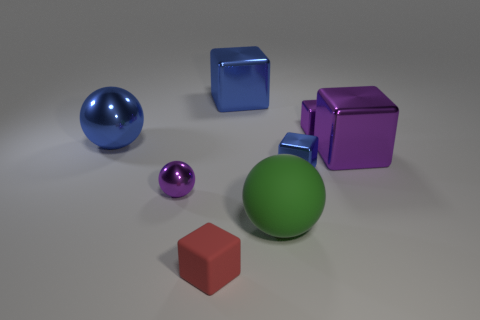Is there a purple sphere of the same size as the red cube?
Provide a short and direct response. Yes. Is the number of brown metal objects less than the number of big metal objects?
Provide a succinct answer. Yes. How many cylinders are either blue matte objects or rubber things?
Your answer should be very brief. 0. How many blocks have the same color as the small ball?
Keep it short and to the point. 2. What size is the purple metal object that is both to the left of the large purple metal cube and behind the tiny blue thing?
Offer a terse response. Small. Is the number of tiny blue metallic cubes that are in front of the small metal sphere less than the number of small cyan metallic balls?
Offer a terse response. No. Is the material of the tiny purple cube the same as the green sphere?
Your answer should be compact. No. What number of objects are small brown rubber cubes or small purple things?
Give a very brief answer. 2. What number of other tiny objects are made of the same material as the green object?
Give a very brief answer. 1. There is a blue shiny object that is the same shape as the green thing; what size is it?
Your answer should be very brief. Large. 